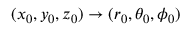<formula> <loc_0><loc_0><loc_500><loc_500>( x _ { 0 } , y _ { 0 } , z _ { 0 } ) \rightarrow ( r _ { 0 } , \theta _ { 0 } , \phi _ { 0 } )</formula> 